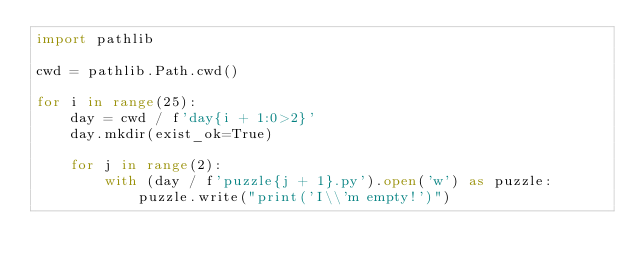<code> <loc_0><loc_0><loc_500><loc_500><_Python_>import pathlib

cwd = pathlib.Path.cwd()

for i in range(25):
    day = cwd / f'day{i + 1:0>2}'
    day.mkdir(exist_ok=True)

    for j in range(2):
        with (day / f'puzzle{j + 1}.py').open('w') as puzzle:
            puzzle.write("print('I\\'m empty!')")
</code> 